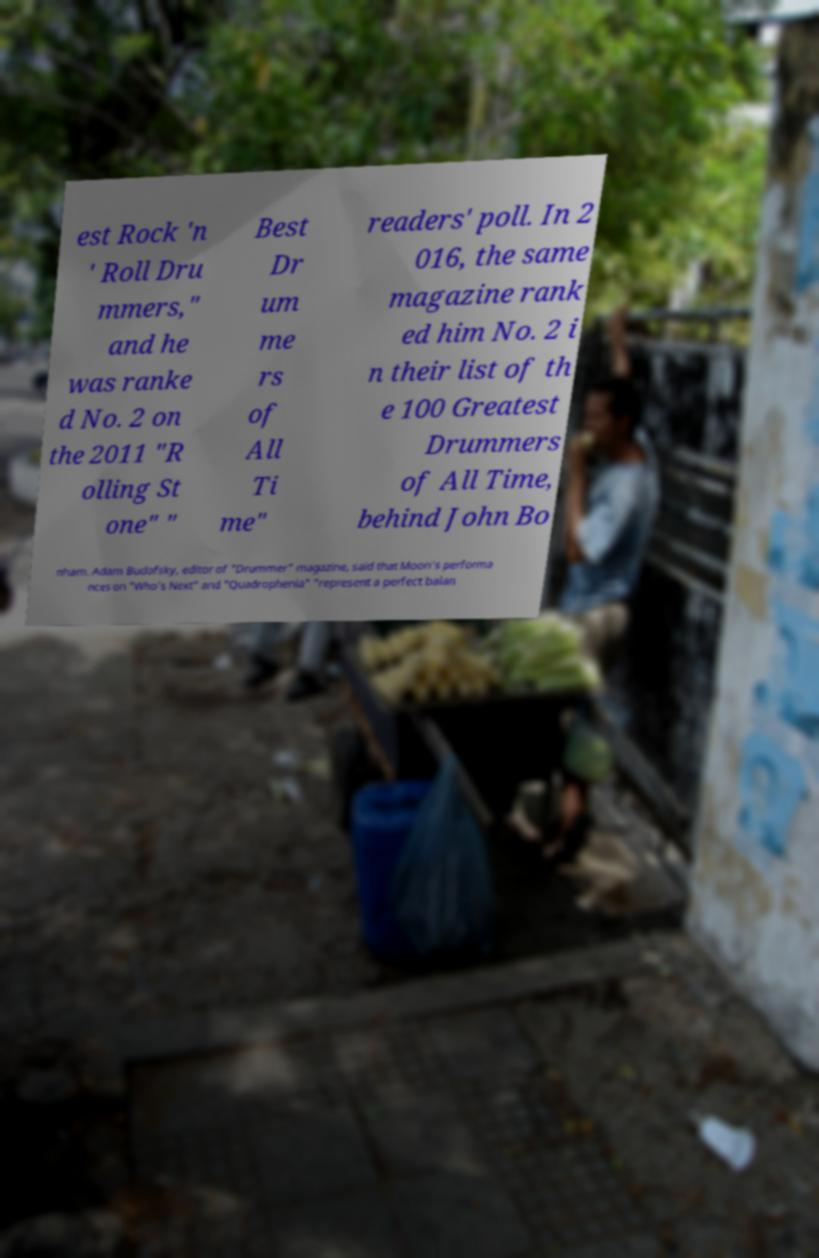There's text embedded in this image that I need extracted. Can you transcribe it verbatim? est Rock 'n ' Roll Dru mmers," and he was ranke d No. 2 on the 2011 "R olling St one" " Best Dr um me rs of All Ti me" readers' poll. In 2 016, the same magazine rank ed him No. 2 i n their list of th e 100 Greatest Drummers of All Time, behind John Bo nham. Adam Budofsky, editor of "Drummer" magazine, said that Moon's performa nces on "Who's Next" and "Quadrophenia" "represent a perfect balan 